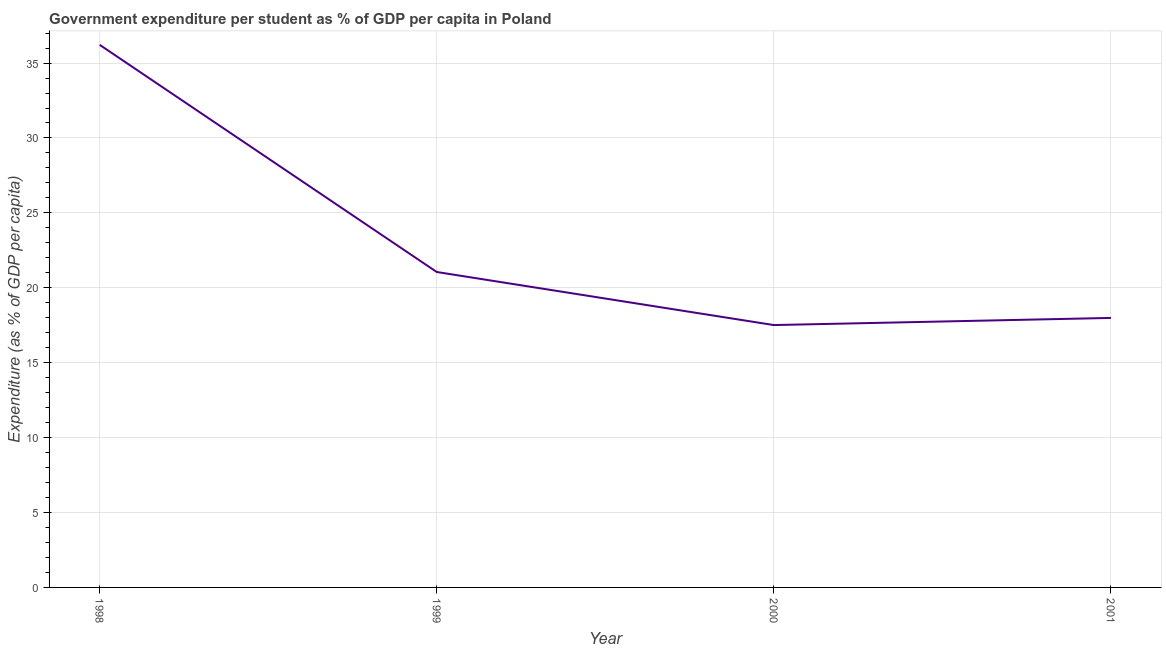What is the government expenditure per student in 2000?
Provide a short and direct response. 17.51. Across all years, what is the maximum government expenditure per student?
Make the answer very short. 36.22. Across all years, what is the minimum government expenditure per student?
Give a very brief answer. 17.51. In which year was the government expenditure per student maximum?
Offer a terse response. 1998. In which year was the government expenditure per student minimum?
Offer a very short reply. 2000. What is the sum of the government expenditure per student?
Provide a succinct answer. 92.77. What is the difference between the government expenditure per student in 1998 and 2001?
Provide a succinct answer. 18.23. What is the average government expenditure per student per year?
Keep it short and to the point. 23.19. What is the median government expenditure per student?
Offer a very short reply. 19.52. In how many years, is the government expenditure per student greater than 7 %?
Provide a succinct answer. 4. Do a majority of the years between 2001 and 1999 (inclusive) have government expenditure per student greater than 22 %?
Your answer should be very brief. No. What is the ratio of the government expenditure per student in 1998 to that in 2000?
Your answer should be compact. 2.07. What is the difference between the highest and the second highest government expenditure per student?
Your answer should be very brief. 15.16. What is the difference between the highest and the lowest government expenditure per student?
Keep it short and to the point. 18.7. How many years are there in the graph?
Keep it short and to the point. 4. Are the values on the major ticks of Y-axis written in scientific E-notation?
Ensure brevity in your answer.  No. Does the graph contain grids?
Ensure brevity in your answer.  Yes. What is the title of the graph?
Keep it short and to the point. Government expenditure per student as % of GDP per capita in Poland. What is the label or title of the X-axis?
Your answer should be very brief. Year. What is the label or title of the Y-axis?
Your response must be concise. Expenditure (as % of GDP per capita). What is the Expenditure (as % of GDP per capita) in 1998?
Provide a succinct answer. 36.22. What is the Expenditure (as % of GDP per capita) of 1999?
Offer a very short reply. 21.05. What is the Expenditure (as % of GDP per capita) of 2000?
Your response must be concise. 17.51. What is the Expenditure (as % of GDP per capita) in 2001?
Offer a very short reply. 17.99. What is the difference between the Expenditure (as % of GDP per capita) in 1998 and 1999?
Offer a terse response. 15.16. What is the difference between the Expenditure (as % of GDP per capita) in 1998 and 2000?
Your answer should be very brief. 18.7. What is the difference between the Expenditure (as % of GDP per capita) in 1998 and 2001?
Offer a terse response. 18.23. What is the difference between the Expenditure (as % of GDP per capita) in 1999 and 2000?
Your answer should be very brief. 3.54. What is the difference between the Expenditure (as % of GDP per capita) in 1999 and 2001?
Offer a very short reply. 3.06. What is the difference between the Expenditure (as % of GDP per capita) in 2000 and 2001?
Your answer should be very brief. -0.48. What is the ratio of the Expenditure (as % of GDP per capita) in 1998 to that in 1999?
Offer a terse response. 1.72. What is the ratio of the Expenditure (as % of GDP per capita) in 1998 to that in 2000?
Your answer should be very brief. 2.07. What is the ratio of the Expenditure (as % of GDP per capita) in 1998 to that in 2001?
Provide a succinct answer. 2.01. What is the ratio of the Expenditure (as % of GDP per capita) in 1999 to that in 2000?
Give a very brief answer. 1.2. What is the ratio of the Expenditure (as % of GDP per capita) in 1999 to that in 2001?
Your response must be concise. 1.17. 